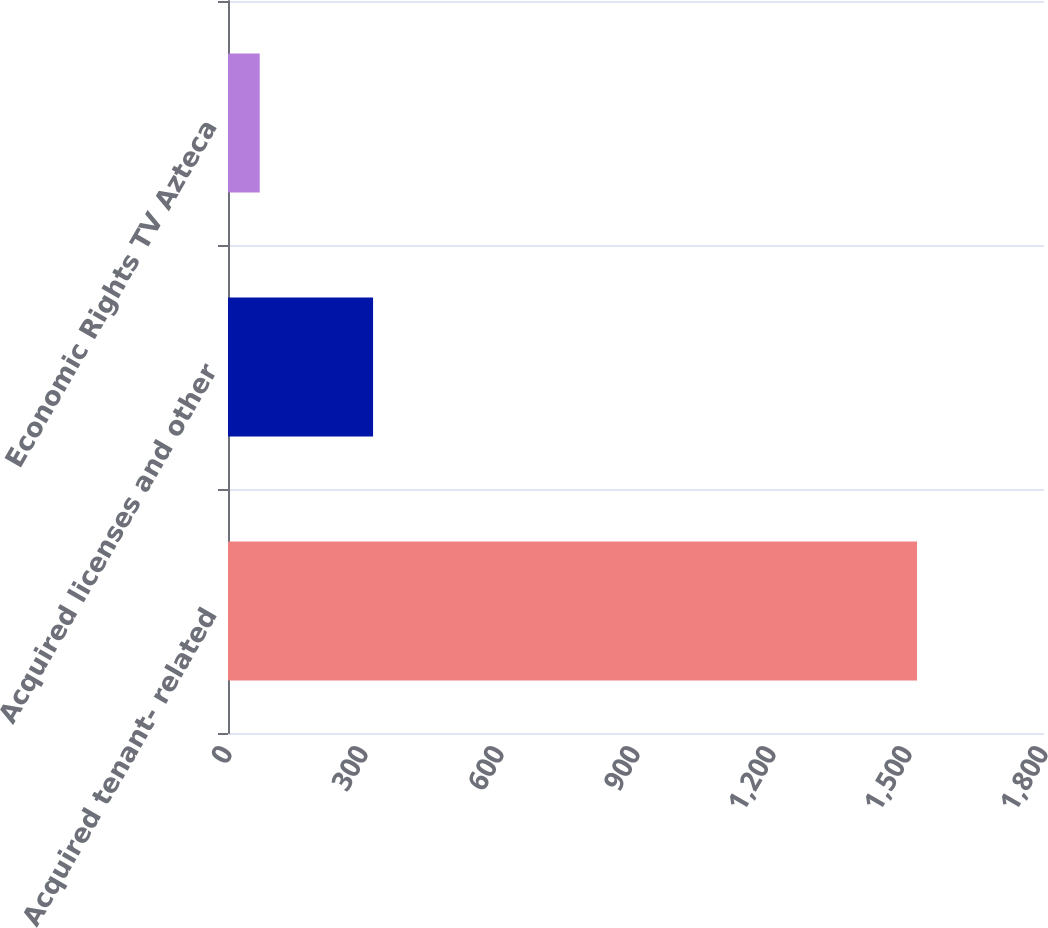Convert chart. <chart><loc_0><loc_0><loc_500><loc_500><bar_chart><fcel>Acquired tenant- related<fcel>Acquired licenses and other<fcel>Economic Rights TV Azteca<nl><fcel>1520<fcel>320<fcel>70<nl></chart> 